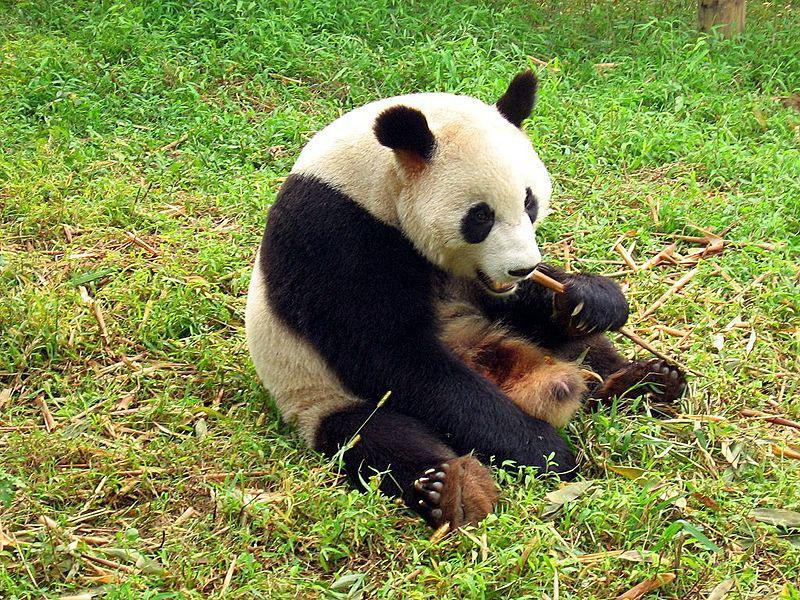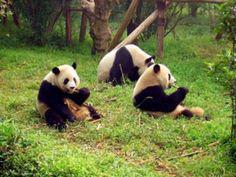The first image is the image on the left, the second image is the image on the right. For the images displayed, is the sentence "Each panda in the image, whose mouth can clearly be seen, is currently eating bamboo." factually correct? Answer yes or no. Yes. 